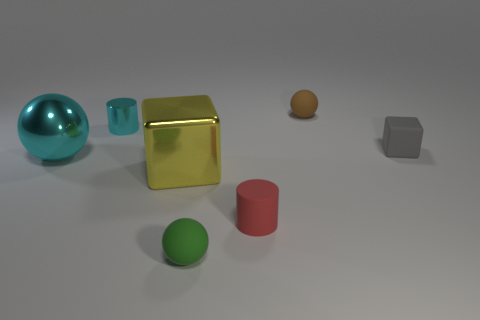Add 3 red rubber cylinders. How many objects exist? 10 Subtract all large cyan metal spheres. How many spheres are left? 2 Subtract 2 cylinders. How many cylinders are left? 0 Subtract all gray blocks. How many blocks are left? 1 Add 2 large yellow objects. How many large yellow objects are left? 3 Add 1 rubber cylinders. How many rubber cylinders exist? 2 Subtract 0 cyan blocks. How many objects are left? 7 Subtract all balls. How many objects are left? 4 Subtract all blue balls. Subtract all blue blocks. How many balls are left? 3 Subtract all tiny brown rubber spheres. Subtract all tiny gray cubes. How many objects are left? 5 